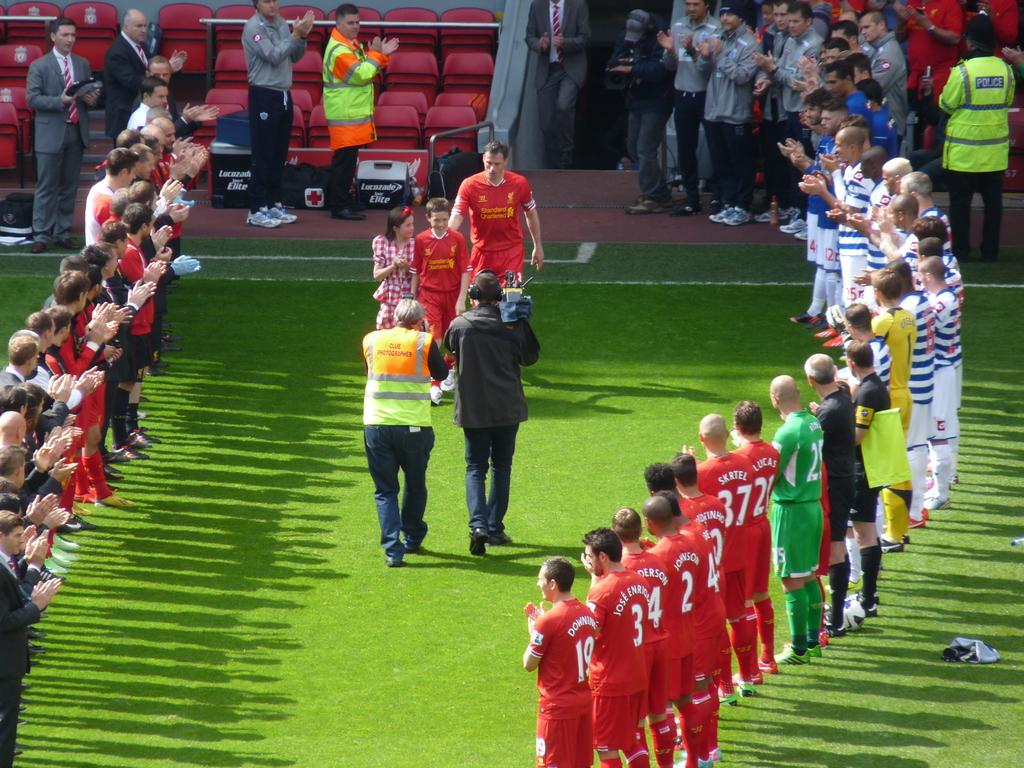<image>
Summarize the visual content of the image. Anderson, Johnson, Lucas and other players stand in a line watching an emotional moment. 